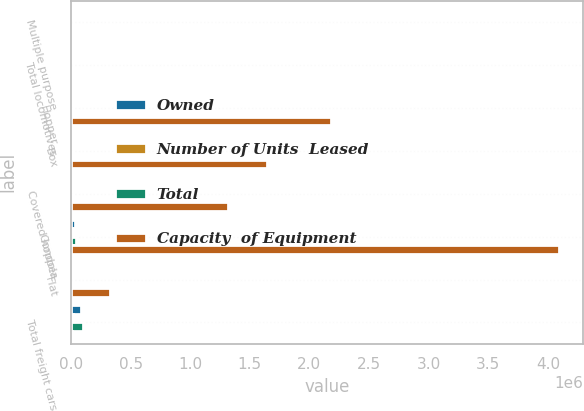Convert chart. <chart><loc_0><loc_0><loc_500><loc_500><stacked_bar_chart><ecel><fcel>Multiple purpose<fcel>Total locomotives<fcel>Hopper<fcel>Box<fcel>Covered hopper<fcel>Gondola<fcel>Flat<fcel>Total freight cars<nl><fcel>Owned<fcel>3323<fcel>3604<fcel>19911<fcel>18712<fcel>9399<fcel>30300<fcel>2928<fcel>85202<nl><fcel>Number of Units  Leased<fcel>151<fcel>151<fcel>822<fcel>2175<fcel>2678<fcel>8010<fcel>1342<fcel>15027<nl><fcel>Total<fcel>3474<fcel>3755<fcel>20733<fcel>20887<fcel>12077<fcel>38310<fcel>4270<fcel>100229<nl><fcel>Capacity  of Equipment<fcel>12077<fcel>12077<fcel>2.18324e+06<fcel>1.64153e+06<fcel>1.31649e+06<fcel>4.09369e+06<fcel>328376<fcel>12077<nl></chart> 